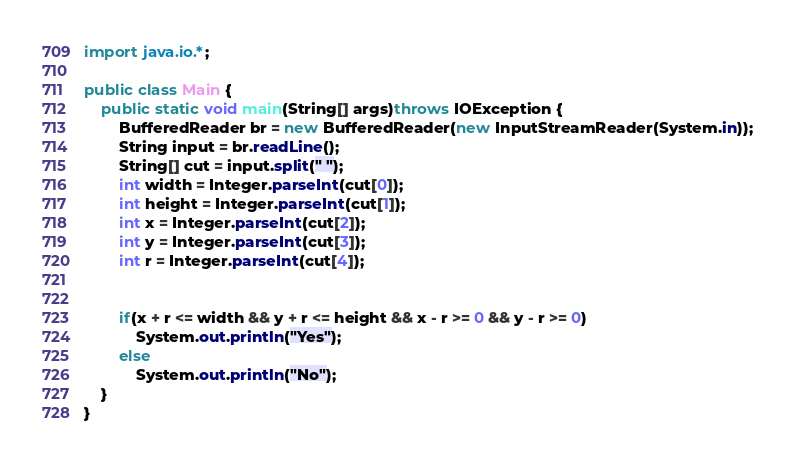<code> <loc_0><loc_0><loc_500><loc_500><_Java_>import java.io.*;
  
public class Main {
    public static void main(String[] args)throws IOException {
        BufferedReader br = new BufferedReader(new InputStreamReader(System.in));
        String input = br.readLine();
        String[] cut = input.split(" ");
        int width = Integer.parseInt(cut[0]);
        int height = Integer.parseInt(cut[1]);
        int x = Integer.parseInt(cut[2]);
        int y = Integer.parseInt(cut[3]);
        int r = Integer.parseInt(cut[4]);
         
         
        if(x + r <= width && y + r <= height && x - r >= 0 && y - r >= 0)
            System.out.println("Yes");
        else
            System.out.println("No");    
    }
}
</code> 